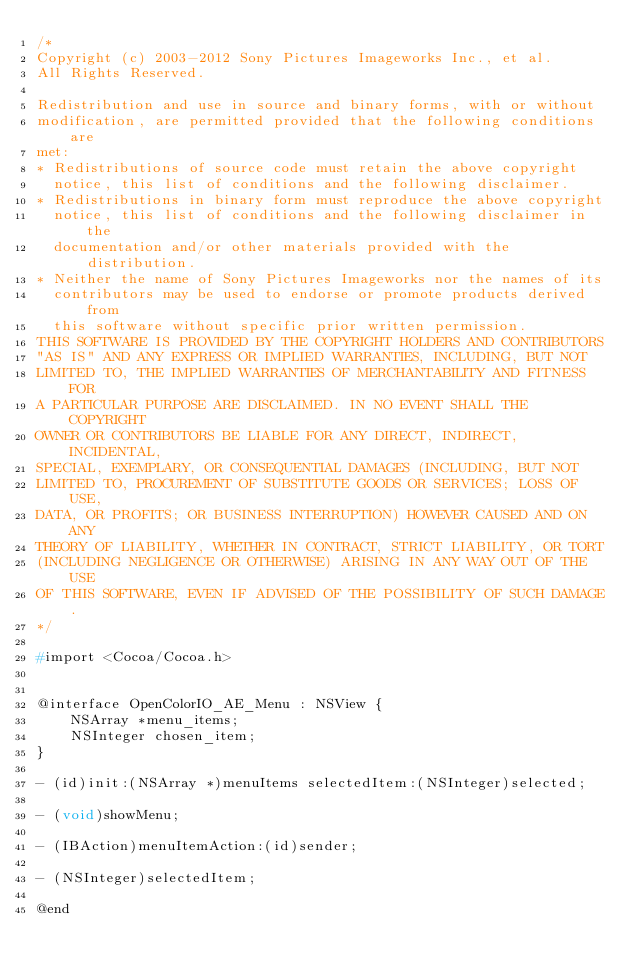Convert code to text. <code><loc_0><loc_0><loc_500><loc_500><_C_>/*
Copyright (c) 2003-2012 Sony Pictures Imageworks Inc., et al.
All Rights Reserved.

Redistribution and use in source and binary forms, with or without
modification, are permitted provided that the following conditions are
met:
* Redistributions of source code must retain the above copyright
  notice, this list of conditions and the following disclaimer.
* Redistributions in binary form must reproduce the above copyright
  notice, this list of conditions and the following disclaimer in the
  documentation and/or other materials provided with the distribution.
* Neither the name of Sony Pictures Imageworks nor the names of its
  contributors may be used to endorse or promote products derived from
  this software without specific prior written permission.
THIS SOFTWARE IS PROVIDED BY THE COPYRIGHT HOLDERS AND CONTRIBUTORS
"AS IS" AND ANY EXPRESS OR IMPLIED WARRANTIES, INCLUDING, BUT NOT
LIMITED TO, THE IMPLIED WARRANTIES OF MERCHANTABILITY AND FITNESS FOR
A PARTICULAR PURPOSE ARE DISCLAIMED. IN NO EVENT SHALL THE COPYRIGHT
OWNER OR CONTRIBUTORS BE LIABLE FOR ANY DIRECT, INDIRECT, INCIDENTAL,
SPECIAL, EXEMPLARY, OR CONSEQUENTIAL DAMAGES (INCLUDING, BUT NOT
LIMITED TO, PROCUREMENT OF SUBSTITUTE GOODS OR SERVICES; LOSS OF USE,
DATA, OR PROFITS; OR BUSINESS INTERRUPTION) HOWEVER CAUSED AND ON ANY
THEORY OF LIABILITY, WHETHER IN CONTRACT, STRICT LIABILITY, OR TORT
(INCLUDING NEGLIGENCE OR OTHERWISE) ARISING IN ANY WAY OUT OF THE USE
OF THIS SOFTWARE, EVEN IF ADVISED OF THE POSSIBILITY OF SUCH DAMAGE.
*/

#import <Cocoa/Cocoa.h>


@interface OpenColorIO_AE_Menu : NSView {
    NSArray *menu_items;
    NSInteger chosen_item;
}

- (id)init:(NSArray *)menuItems selectedItem:(NSInteger)selected;

- (void)showMenu;

- (IBAction)menuItemAction:(id)sender;

- (NSInteger)selectedItem;

@end
</code> 